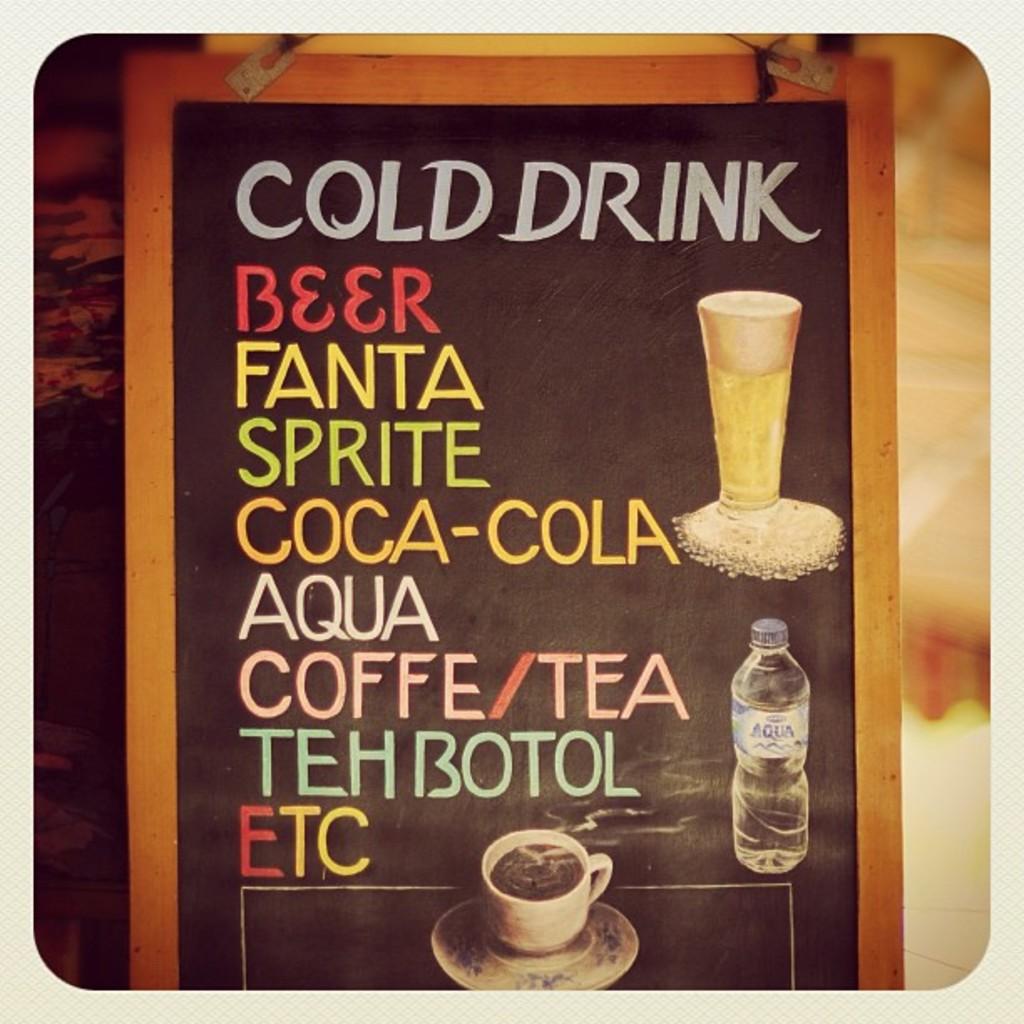What is the title of the board?
Offer a very short reply. Cold drink. What are the drinks listed?
Your response must be concise. Beer fant sprite aque tea. 